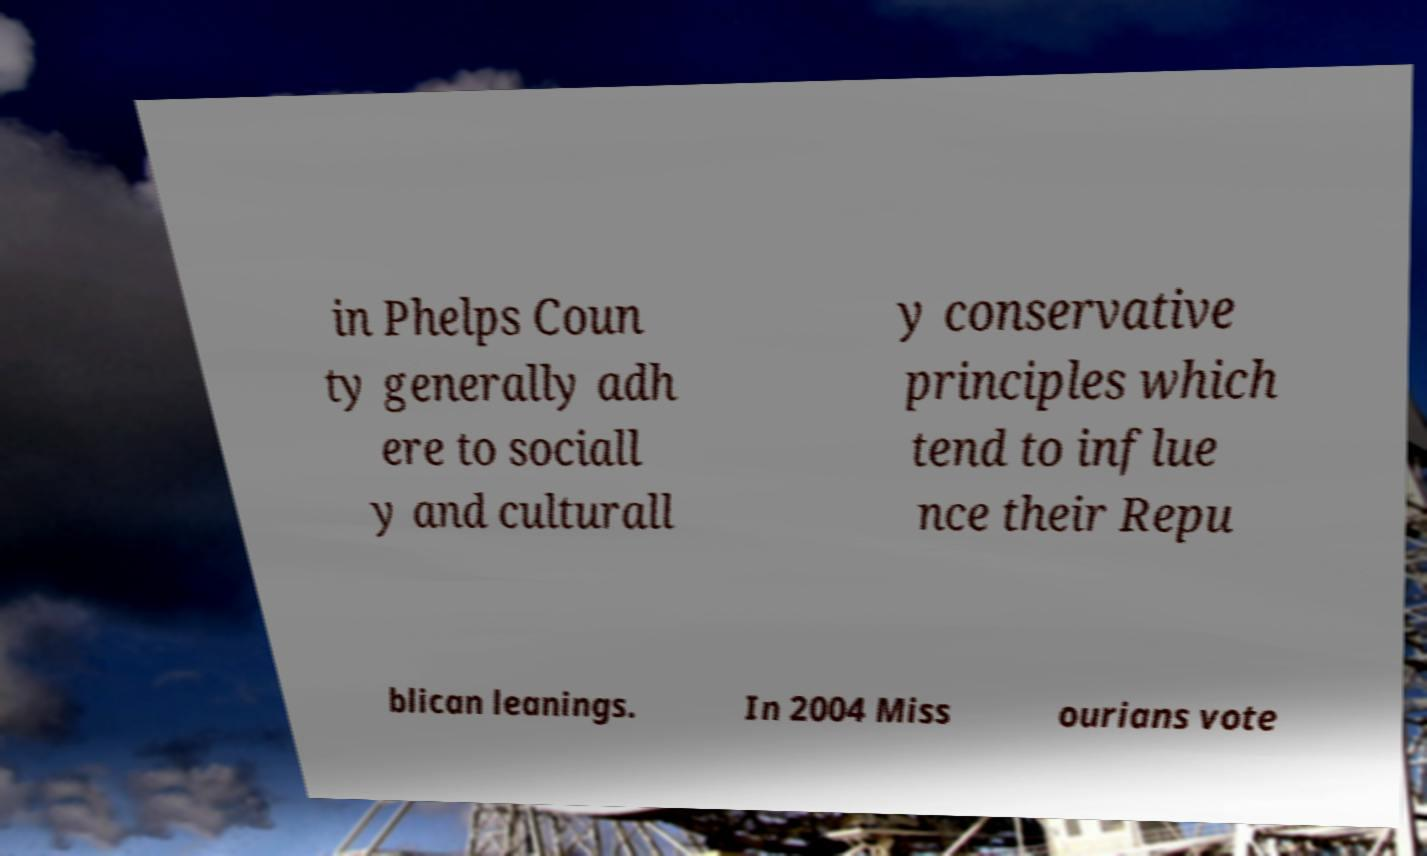Could you assist in decoding the text presented in this image and type it out clearly? in Phelps Coun ty generally adh ere to sociall y and culturall y conservative principles which tend to influe nce their Repu blican leanings. In 2004 Miss ourians vote 